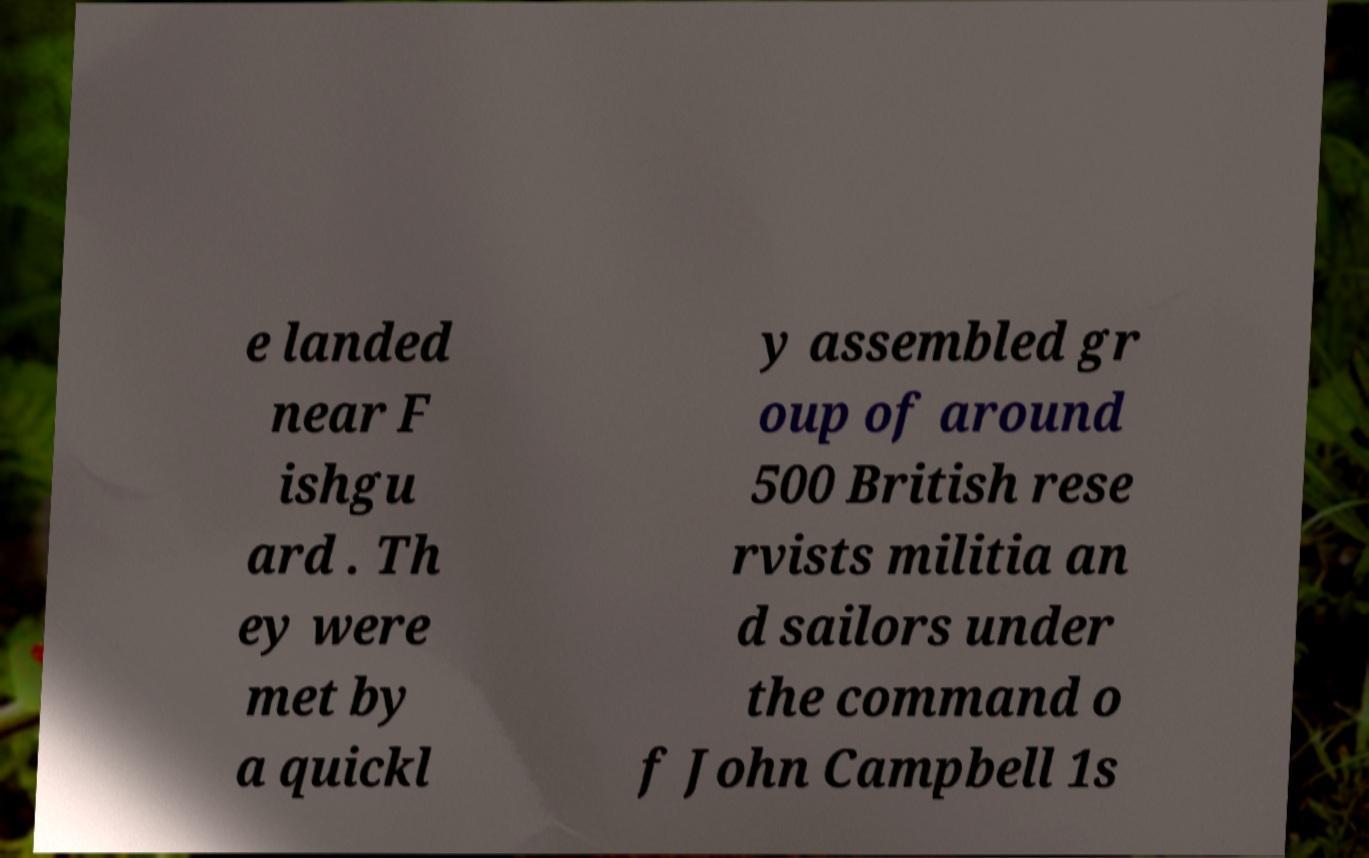Can you read and provide the text displayed in the image?This photo seems to have some interesting text. Can you extract and type it out for me? e landed near F ishgu ard . Th ey were met by a quickl y assembled gr oup of around 500 British rese rvists militia an d sailors under the command o f John Campbell 1s 